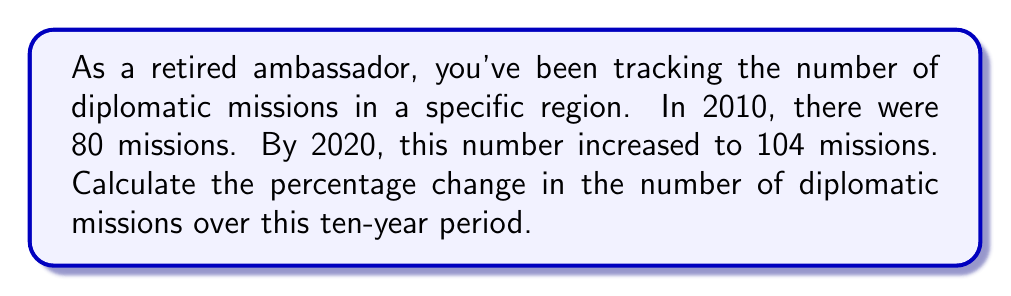Could you help me with this problem? To calculate the percentage change, we'll follow these steps:

1. Find the change in the number of missions:
   $\text{Change} = \text{Final value} - \text{Initial value}$
   $\text{Change} = 104 - 80 = 24$

2. Calculate the percentage change using the formula:
   $$\text{Percentage change} = \frac{\text{Change}}{\text{Initial value}} \times 100\%$$

3. Substitute the values:
   $$\text{Percentage change} = \frac{24}{80} \times 100\%$$

4. Simplify the fraction:
   $$\text{Percentage change} = 0.3 \times 100\%$$

5. Calculate the final result:
   $$\text{Percentage change} = 30\%$$

The number of diplomatic missions increased by 30% over the ten-year period.
Answer: 30% 